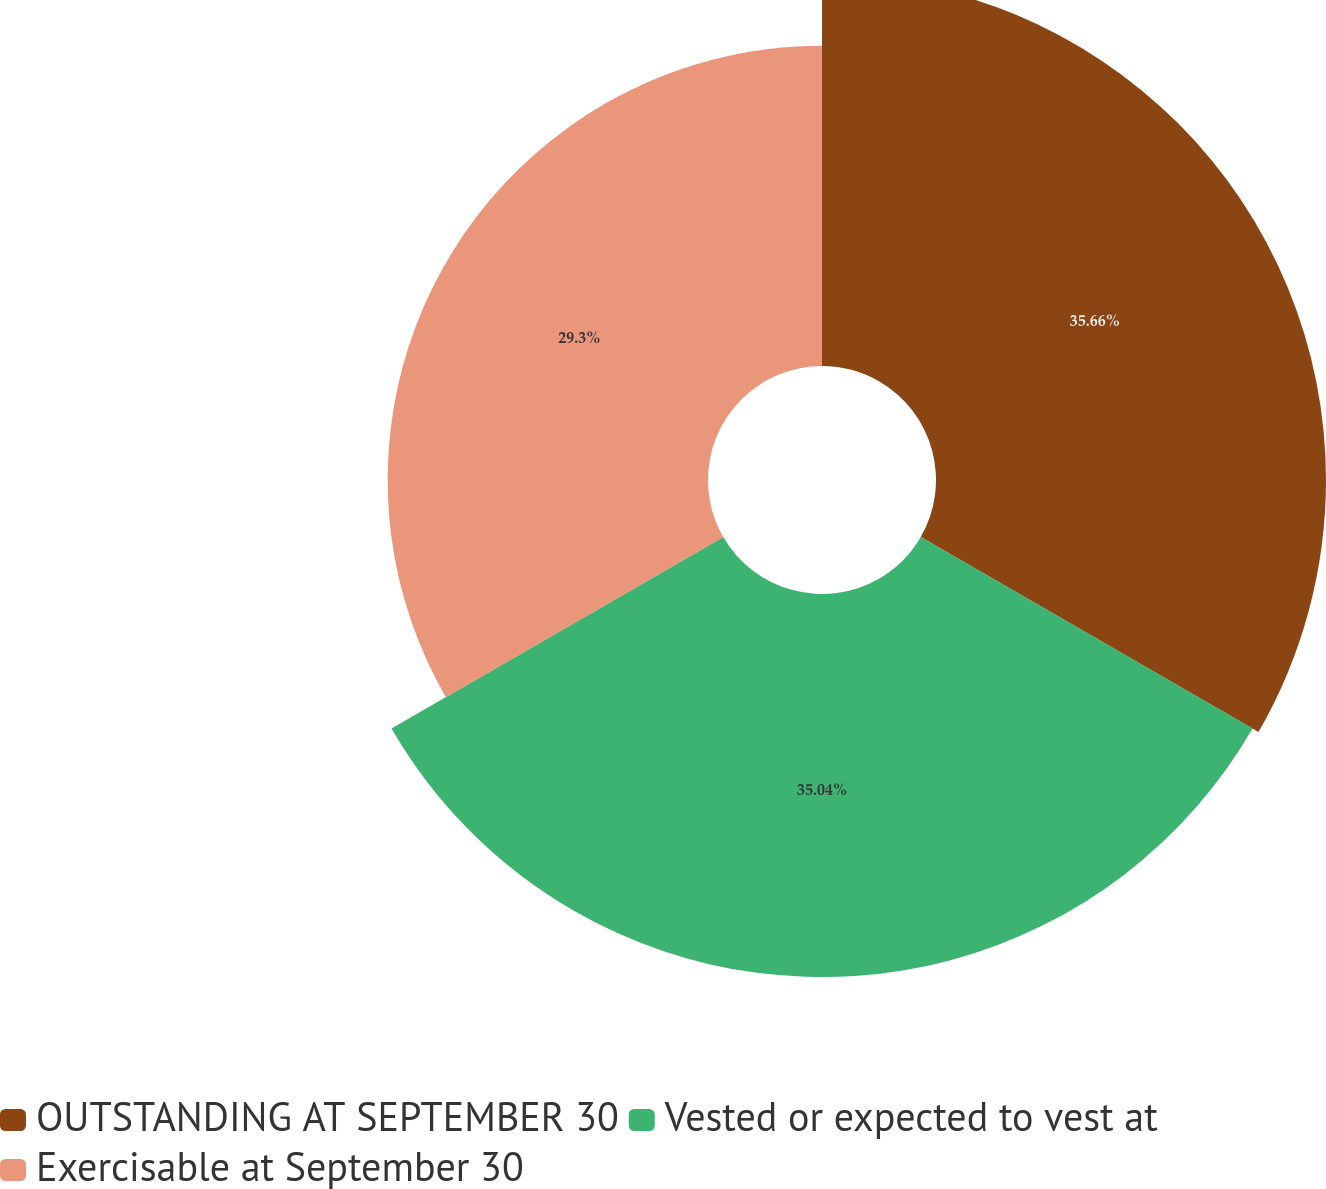Convert chart to OTSL. <chart><loc_0><loc_0><loc_500><loc_500><pie_chart><fcel>OUTSTANDING AT SEPTEMBER 30<fcel>Vested or expected to vest at<fcel>Exercisable at September 30<nl><fcel>35.67%<fcel>35.04%<fcel>29.3%<nl></chart> 